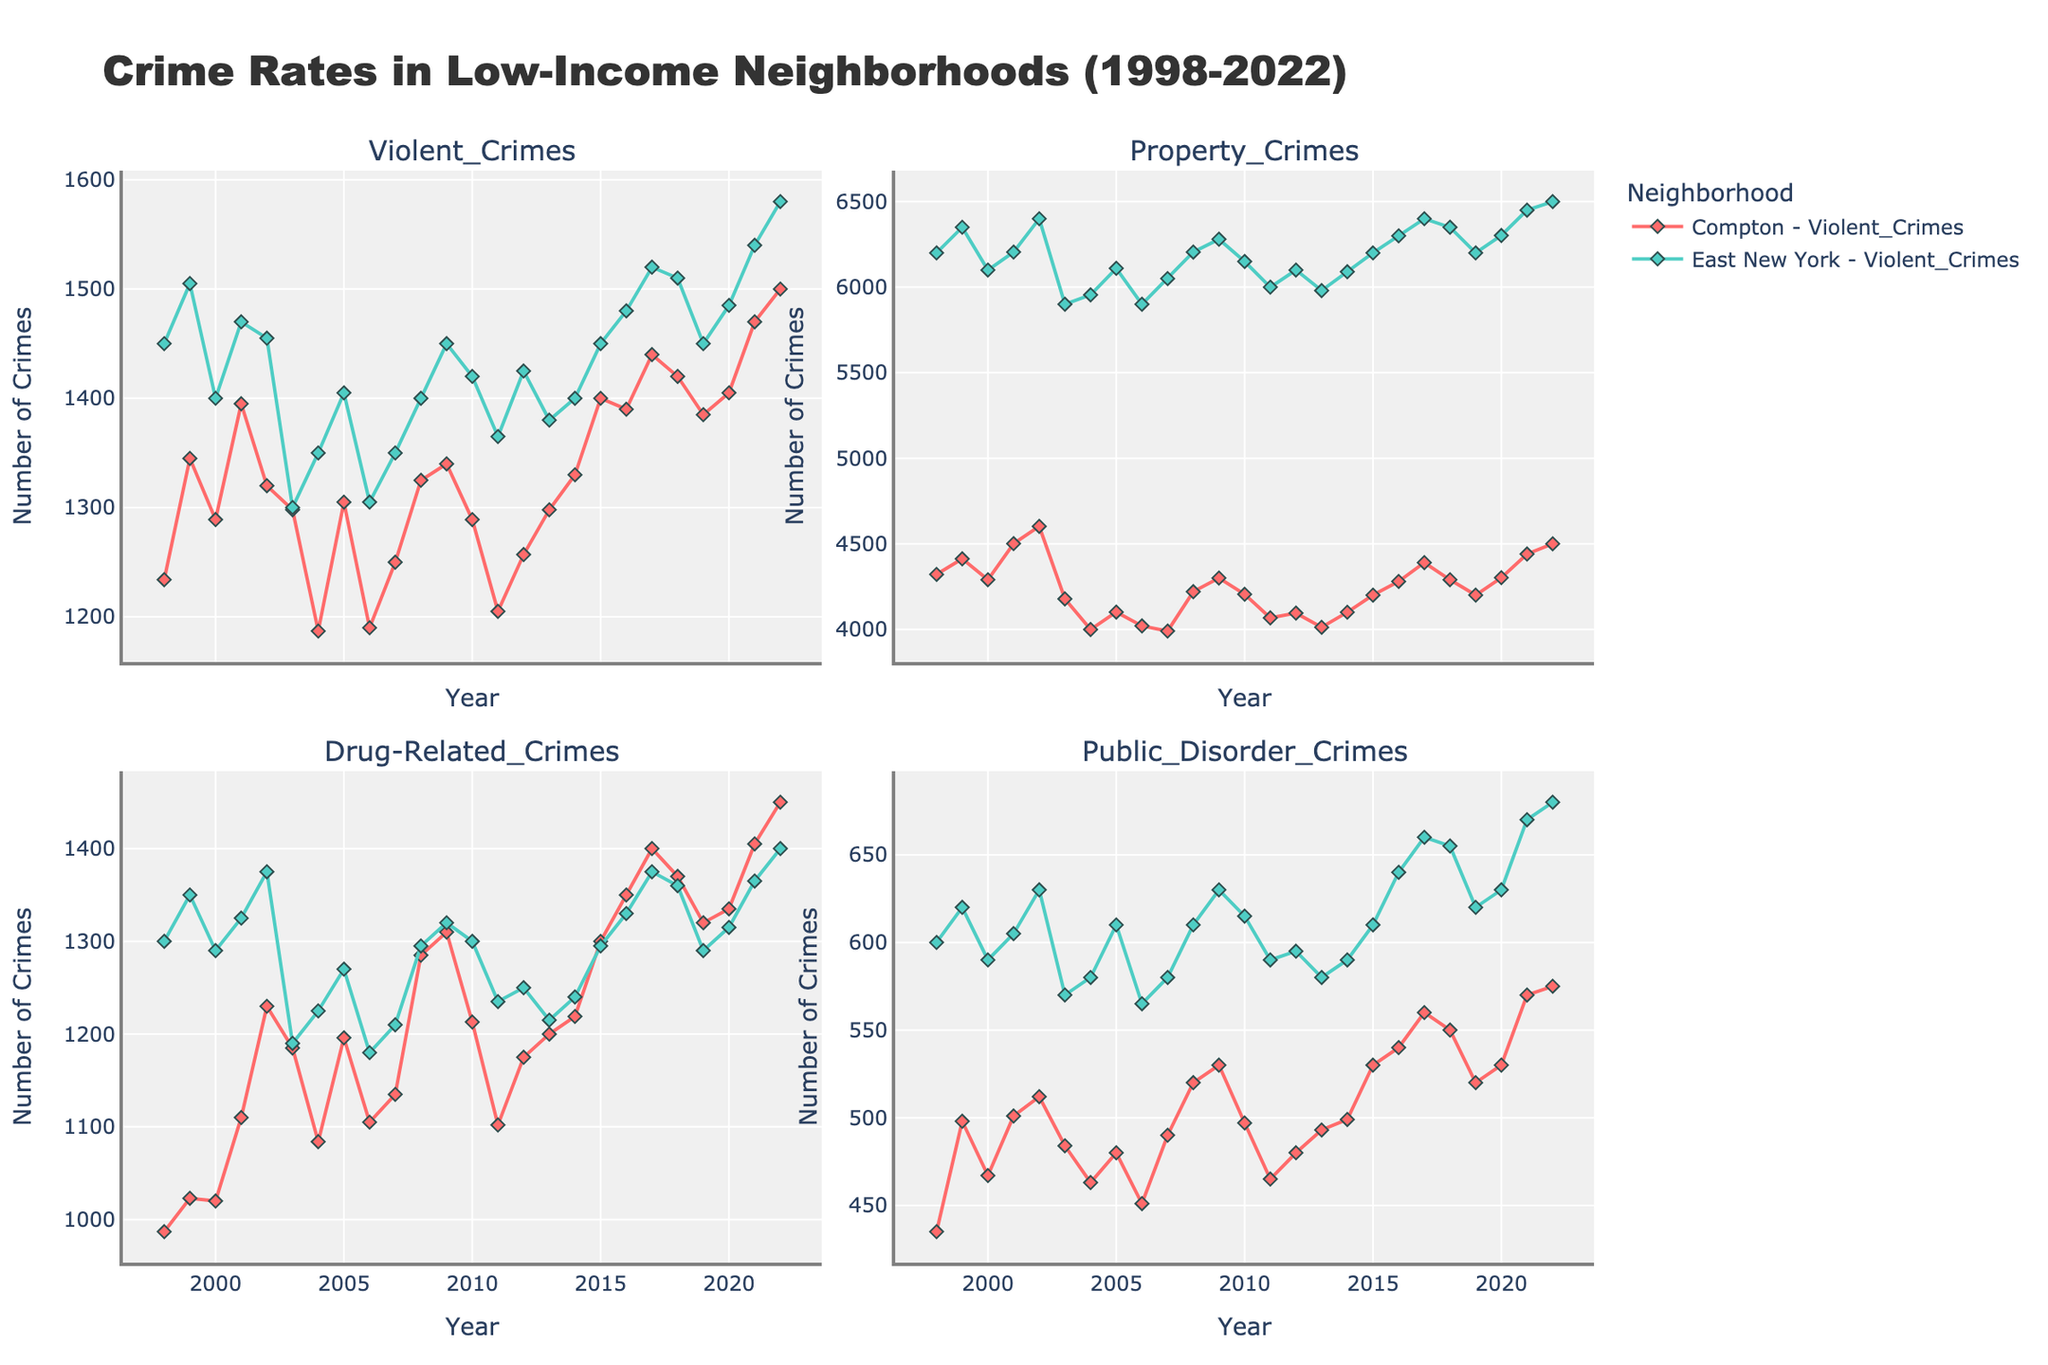What is the title of the plot? The title of the plot is displayed at the top center of the figure. It provides an overview of the content being represented.
Answer: Crime Rates in Low-Income Neighborhoods (1998-2022) Which neighborhood experienced a higher number of violent crimes in 2022? By examining the first subplot (Violent Crimes) and looking at the data points for 2022, we can see which neighborhood has the higher value.
Answer: East New York What were the trends in Property Crimes for Compton between 2000 and 2010? By looking at the Property Crimes subplot, you can see the trend line for Compton from the year 2000 to 2010. Identify any increases, decreases, or stability in the data points.
Answer: Fluctuated with overall slight decline Which crime type saw the highest increase in East New York from 2018 to 2022? By comparing the slopes of the lines for East New York across all four subplots from 2018 to 2022, we identify the crime type with the steepest upward trend.
Answer: Violent Crimes In Compton, which year observed the highest number of Public Disorder Crimes, and what was the count? Find the highest peak in the Public Disorder Crimes subplot for Compton, and read the corresponding year and value from the plot.
Answer: 2022, 575 How does the trend of Drug-Related Crimes in Compton compare to East New York from 2015 to 2019? Look at the Drug-Related Crimes subplot for both neighborhoods and compare their data points between 2015 and 2019. Describe whether they are increasing, decreasing, or stable.
Answer: Both increasing What is the average number of Property Crimes in East New York over the 25-year period? Find all the data points for Property Crimes in East New York, sum them up, and then divide by the number of years (25) to calculate the average.
Answer: 6172 Which crime type has the least variation in Compton? By observing the four crime type subplots for Compton, identify the line that shows the least dramatic changes over time.
Answer: Public Disorder Crimes Between Compton and East New York, which neighborhood showed a more consistent rate in Violent Crimes from 2000 to 2010? In the Violent Crimes subplot, compare the variability of the data points for both neighborhoods between 2000 and 2010, and identify which one has a steadier line.
Answer: Compton What can be inferred about the overall crime trend in East New York across all types of crimes from 1998 to 2022? Look at the general direction and significant changes in all four subplots for East New York, and summarize whether crime is generally increasing, decreasing, or fluctuating.
Answer: Generally increasing 